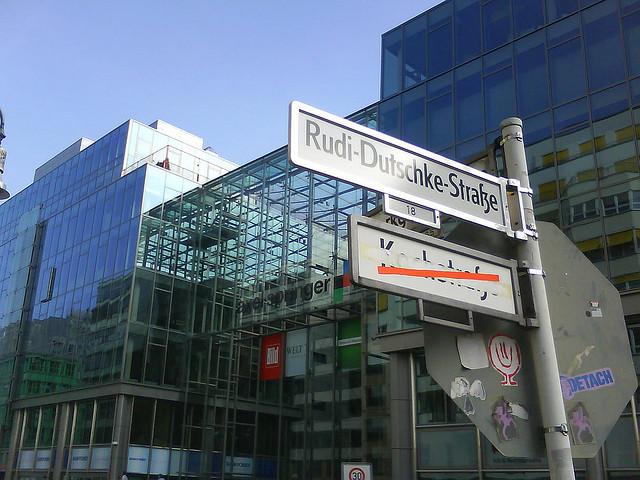What color are the signs?
Keep it brief. White. Where is this picture taken at?
Short answer required. Germany. What does the sign say?
Be succinct. Rudi-dutschke-strasse. What kind of pictographs are on the sign?
Quick response, please. Letters. Is the street called Broadway?
Be succinct. No. Is this a German street sign?
Concise answer only. Yes. How many street signs are pictured?
Short answer required. 3. Was this photo taken in the United States?
Short answer required. No. 